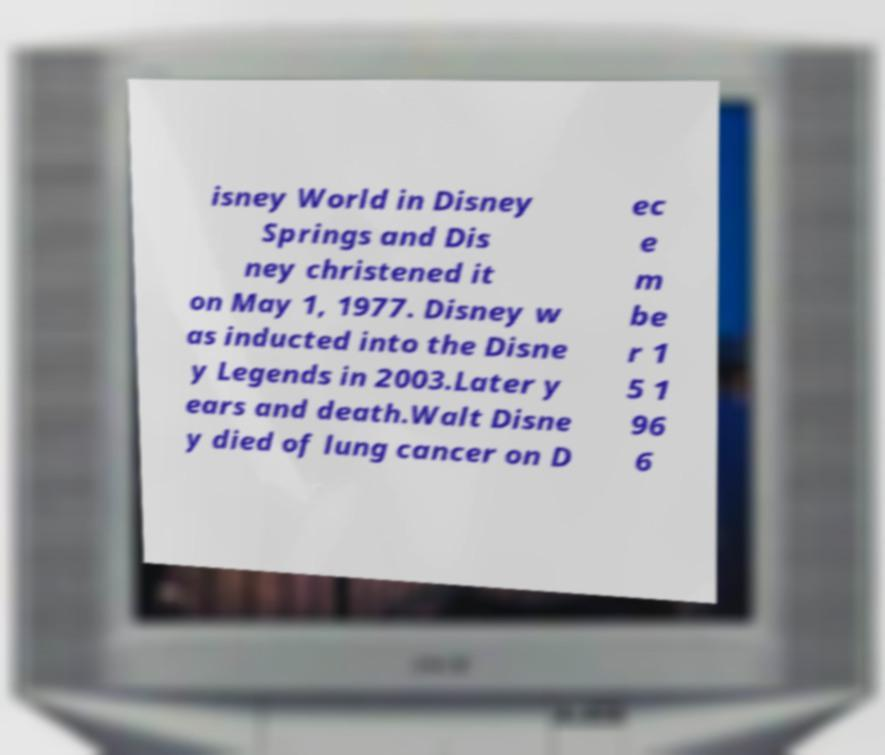Please identify and transcribe the text found in this image. isney World in Disney Springs and Dis ney christened it on May 1, 1977. Disney w as inducted into the Disne y Legends in 2003.Later y ears and death.Walt Disne y died of lung cancer on D ec e m be r 1 5 1 96 6 